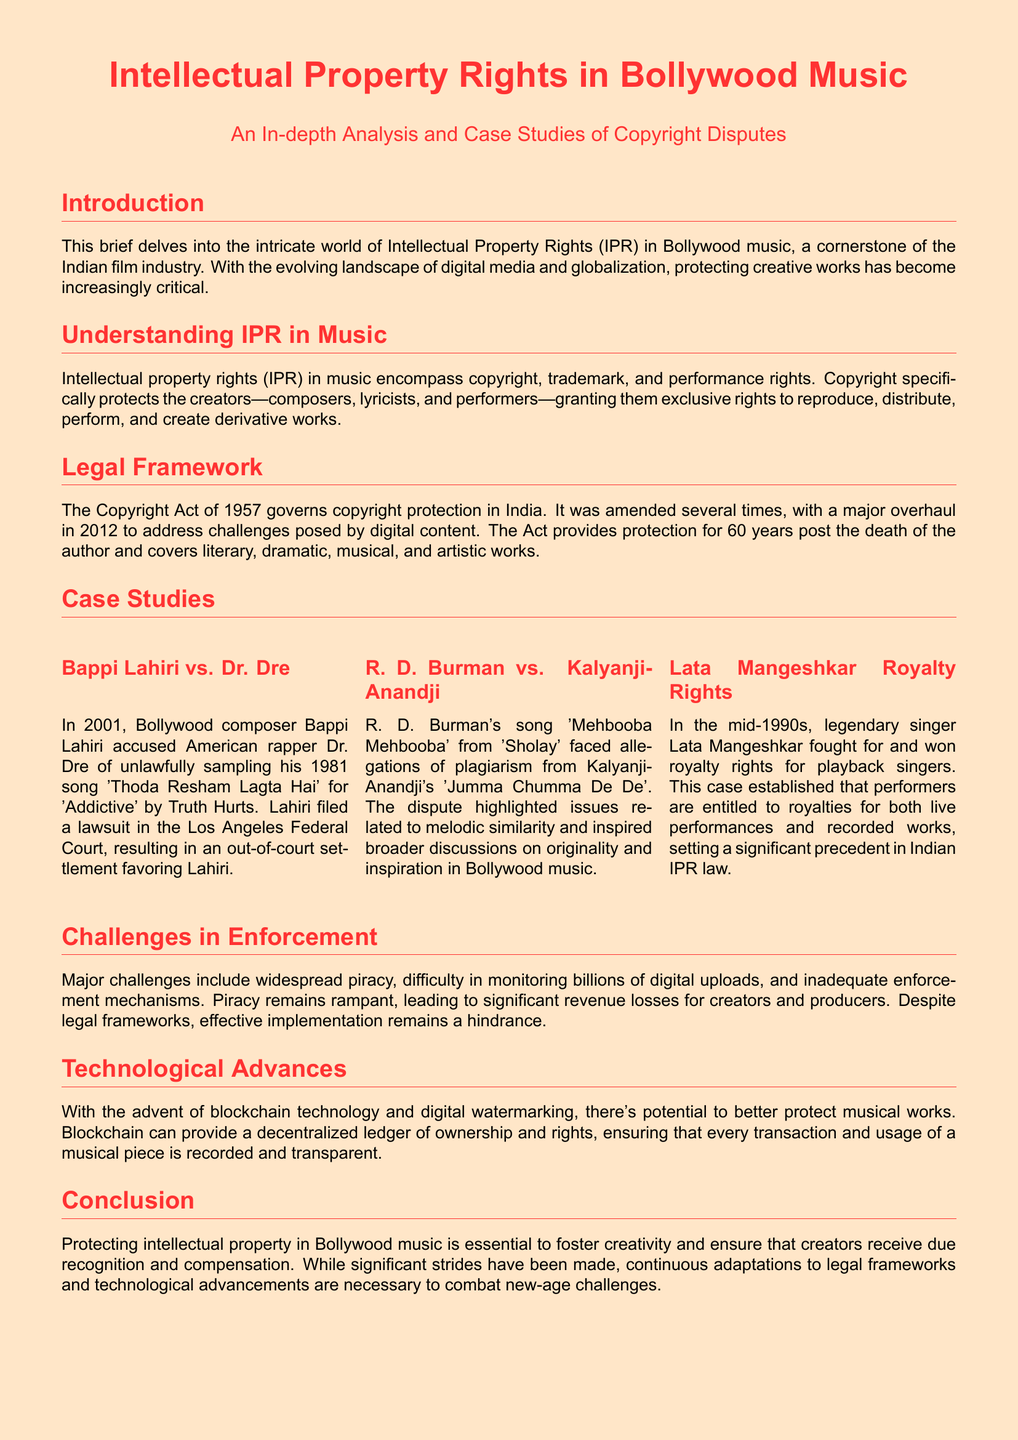What is the title of the document? The title of the document is prominently stated at the beginning, which is about Intellectual Property Rights in Bollywood Music.
Answer: Intellectual Property Rights in Bollywood Music What year was the Copyright Act amended? The document states that the Copyright Act was amended several times, with a major overhaul in 2012.
Answer: 2012 Who accused Dr. Dre of unlawful sampling? According to the case study mentioned in the document, Bappi Lahiri accused Dr. Dre of unlawfully sampling his song.
Answer: Bappi Lahiri What song was at the center of the R. D. Burman plagiarism dispute? The document highlights the song "Mehbooba Mehbooba" as the focus of the plagiarism allegations.
Answer: Mehbooba Mehbooba What major issue affects the enforcement of intellectual property rights in Bollywood music? The document identifies widespread piracy as a significant challenge in enforcing IPR.
Answer: Widespread piracy What technological advance is mentioned as a potential solution for protecting musical works? The document discusses blockchain technology as a promising advancement for better protection of music.
Answer: Blockchain technology In what decade did Lata Mangeshkar fight for royalty rights? The document states that Lata Mangeshkar fought for royalty rights in the mid-1990s.
Answer: Mid-1990s What is the overarching importance of protecting intellectual property in Bollywood music? The conclusion emphasizes the significance of protecting IPR to foster creativity and ensure proper recognition.
Answer: Foster creativity and ensure recognition 